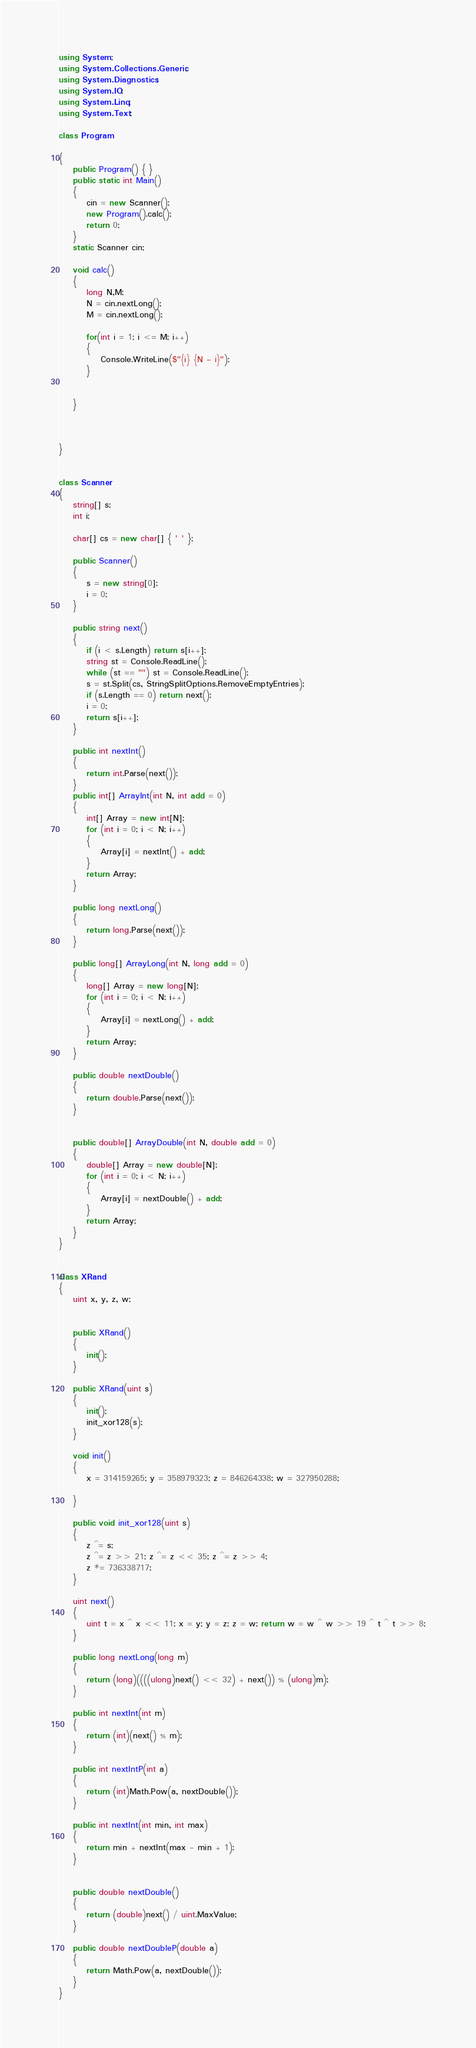Convert code to text. <code><loc_0><loc_0><loc_500><loc_500><_C#_>using System;
using System.Collections.Generic;
using System.Diagnostics;
using System.IO;
using System.Linq;
using System.Text;

class Program

{
    public Program() { }
    public static int Main()
    {
        cin = new Scanner();
        new Program().calc();
        return 0;
    }
    static Scanner cin;

    void calc()
    {
        long N,M;
        N = cin.nextLong();
        M = cin.nextLong();

        for(int i = 1; i <= M; i++)
        {
            Console.WriteLine($"{i} {N - i}");
        }


    }



}


class Scanner
{
    string[] s;
    int i;

    char[] cs = new char[] { ' ' };

    public Scanner()
    {
        s = new string[0];
        i = 0;
    }

    public string next()
    {
        if (i < s.Length) return s[i++];
        string st = Console.ReadLine();
        while (st == "") st = Console.ReadLine();
        s = st.Split(cs, StringSplitOptions.RemoveEmptyEntries);
        if (s.Length == 0) return next();
        i = 0;
        return s[i++];
    }

    public int nextInt()
    {
        return int.Parse(next());
    }
    public int[] ArrayInt(int N, int add = 0)
    {
        int[] Array = new int[N];
        for (int i = 0; i < N; i++)
        {
            Array[i] = nextInt() + add;
        }
        return Array;
    }

    public long nextLong()
    {
        return long.Parse(next());
    }

    public long[] ArrayLong(int N, long add = 0)
    {
        long[] Array = new long[N];
        for (int i = 0; i < N; i++)
        {
            Array[i] = nextLong() + add;
        }
        return Array;
    }

    public double nextDouble()
    {
        return double.Parse(next());
    }


    public double[] ArrayDouble(int N, double add = 0)
    {
        double[] Array = new double[N];
        for (int i = 0; i < N; i++)
        {
            Array[i] = nextDouble() + add;
        }
        return Array;
    }
}


class XRand
{
    uint x, y, z, w;


    public XRand()
    {
        init();
    }

    public XRand(uint s)
    {
        init();
        init_xor128(s);
    }

    void init()
    {
        x = 314159265; y = 358979323; z = 846264338; w = 327950288;

    }

    public void init_xor128(uint s)
    {
        z ^= s;
        z ^= z >> 21; z ^= z << 35; z ^= z >> 4;
        z *= 736338717;
    }

    uint next()
    {
        uint t = x ^ x << 11; x = y; y = z; z = w; return w = w ^ w >> 19 ^ t ^ t >> 8;
    }

    public long nextLong(long m)
    {
        return (long)((((ulong)next() << 32) + next()) % (ulong)m);
    }

    public int nextInt(int m)
    {
        return (int)(next() % m);
    }

    public int nextIntP(int a)
    {
        return (int)Math.Pow(a, nextDouble());
    }

    public int nextInt(int min, int max)
    {
        return min + nextInt(max - min + 1);
    }


    public double nextDouble()
    {
        return (double)next() / uint.MaxValue;
    }

    public double nextDoubleP(double a)
    {
        return Math.Pow(a, nextDouble());
    }
}</code> 